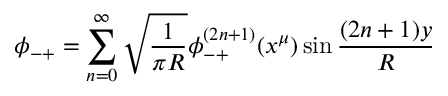Convert formula to latex. <formula><loc_0><loc_0><loc_500><loc_500>\phi _ { - + } = \sum _ { n = 0 } ^ { \infty } \sqrt { \frac { 1 } { \pi R } } \phi _ { - + } ^ { ( 2 n + 1 ) } ( x ^ { \mu } ) \sin \frac { ( 2 n + 1 ) y } { R }</formula> 